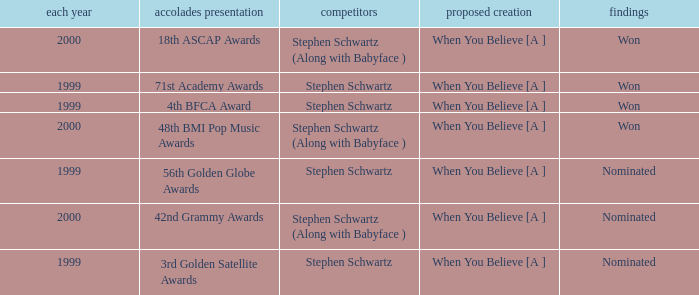What was the results of the 71st Academy Awards show? Won. Write the full table. {'header': ['each year', 'accolades presentation', 'competitors', 'proposed creation', 'findings'], 'rows': [['2000', '18th ASCAP Awards', 'Stephen Schwartz (Along with Babyface )', 'When You Believe [A ]', 'Won'], ['1999', '71st Academy Awards', 'Stephen Schwartz', 'When You Believe [A ]', 'Won'], ['1999', '4th BFCA Award', 'Stephen Schwartz', 'When You Believe [A ]', 'Won'], ['2000', '48th BMI Pop Music Awards', 'Stephen Schwartz (Along with Babyface )', 'When You Believe [A ]', 'Won'], ['1999', '56th Golden Globe Awards', 'Stephen Schwartz', 'When You Believe [A ]', 'Nominated'], ['2000', '42nd Grammy Awards', 'Stephen Schwartz (Along with Babyface )', 'When You Believe [A ]', 'Nominated'], ['1999', '3rd Golden Satellite Awards', 'Stephen Schwartz', 'When You Believe [A ]', 'Nominated']]} 